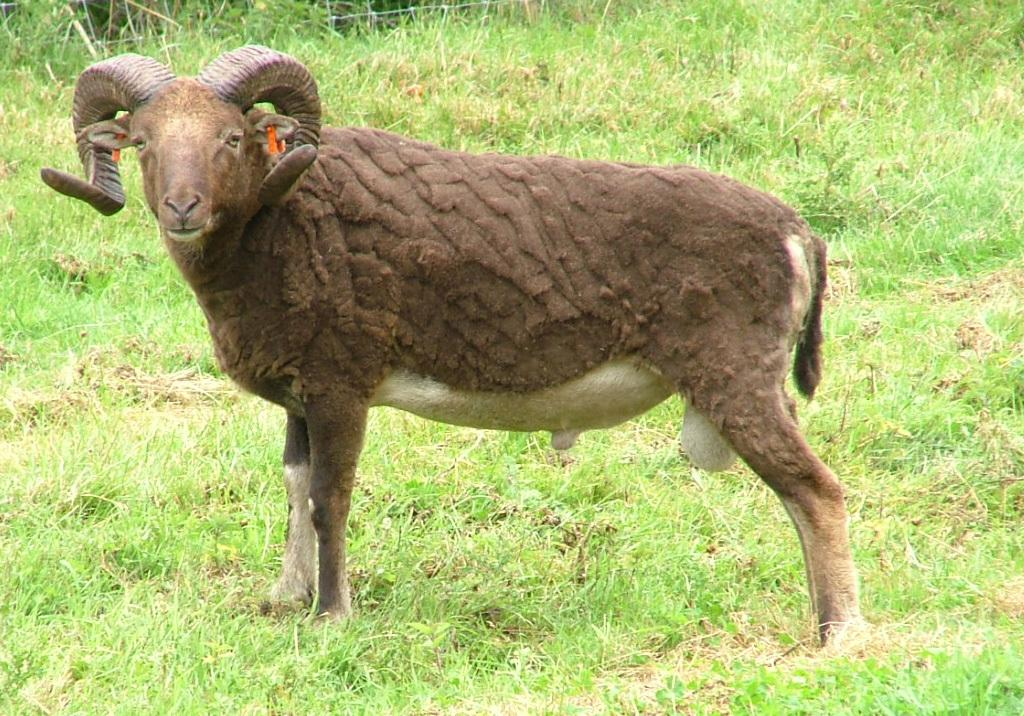What is the main subject of the image? The main subject of the image is a ship. How is the ship positioned in the image? The ship is standing on the ground in the image. What type of terrain is visible at the bottom of the image? There is grass visible at the bottom of the image. Can you tell me how much cheese the sheep in the image is carrying? There are no sheep or cheese present in the image; it features a ship standing on the ground with grass visible at the bottom. 